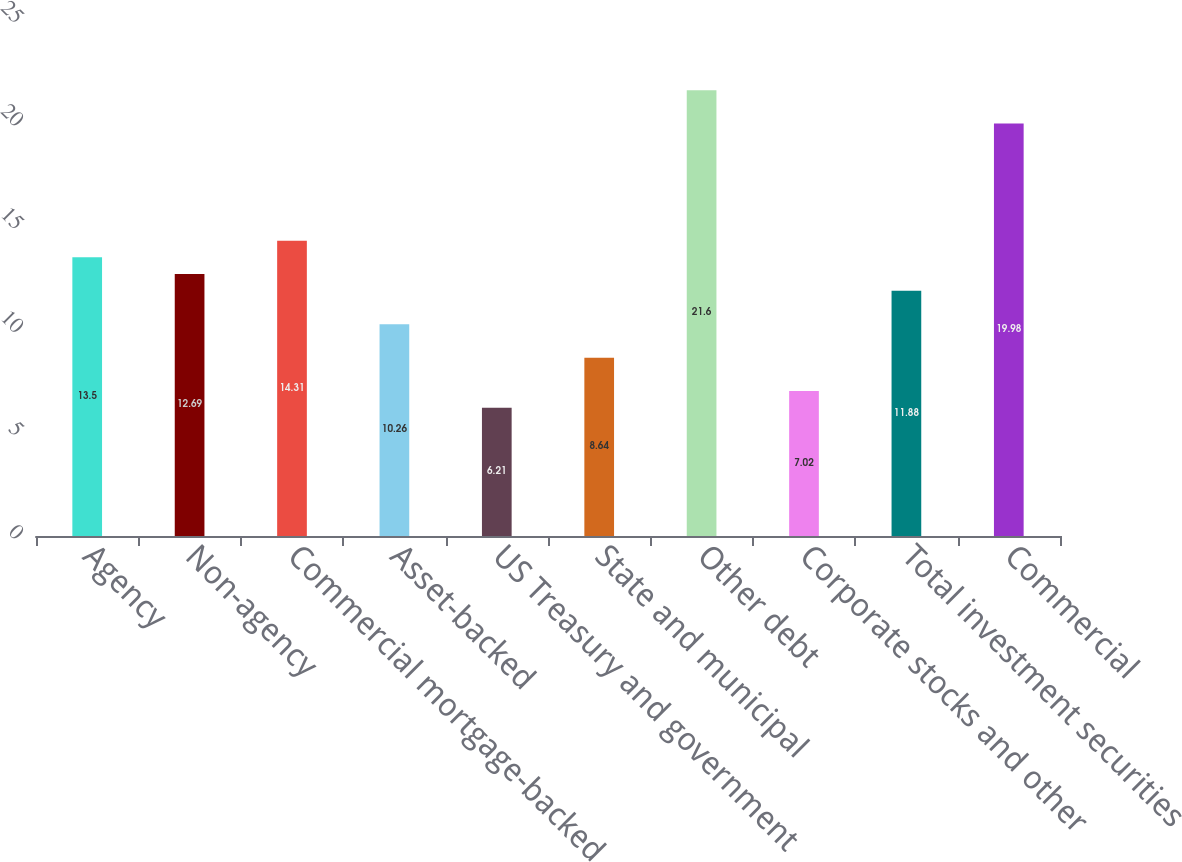Convert chart to OTSL. <chart><loc_0><loc_0><loc_500><loc_500><bar_chart><fcel>Agency<fcel>Non-agency<fcel>Commercial mortgage-backed<fcel>Asset-backed<fcel>US Treasury and government<fcel>State and municipal<fcel>Other debt<fcel>Corporate stocks and other<fcel>Total investment securities<fcel>Commercial<nl><fcel>13.5<fcel>12.69<fcel>14.31<fcel>10.26<fcel>6.21<fcel>8.64<fcel>21.6<fcel>7.02<fcel>11.88<fcel>19.98<nl></chart> 